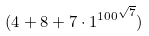<formula> <loc_0><loc_0><loc_500><loc_500>( 4 + 8 + 7 \cdot { 1 ^ { 1 0 0 } } ^ { \sqrt { 7 } } )</formula> 